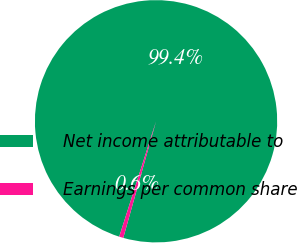<chart> <loc_0><loc_0><loc_500><loc_500><pie_chart><fcel>Net income attributable to<fcel>Earnings per common share<nl><fcel>99.44%<fcel>0.56%<nl></chart> 